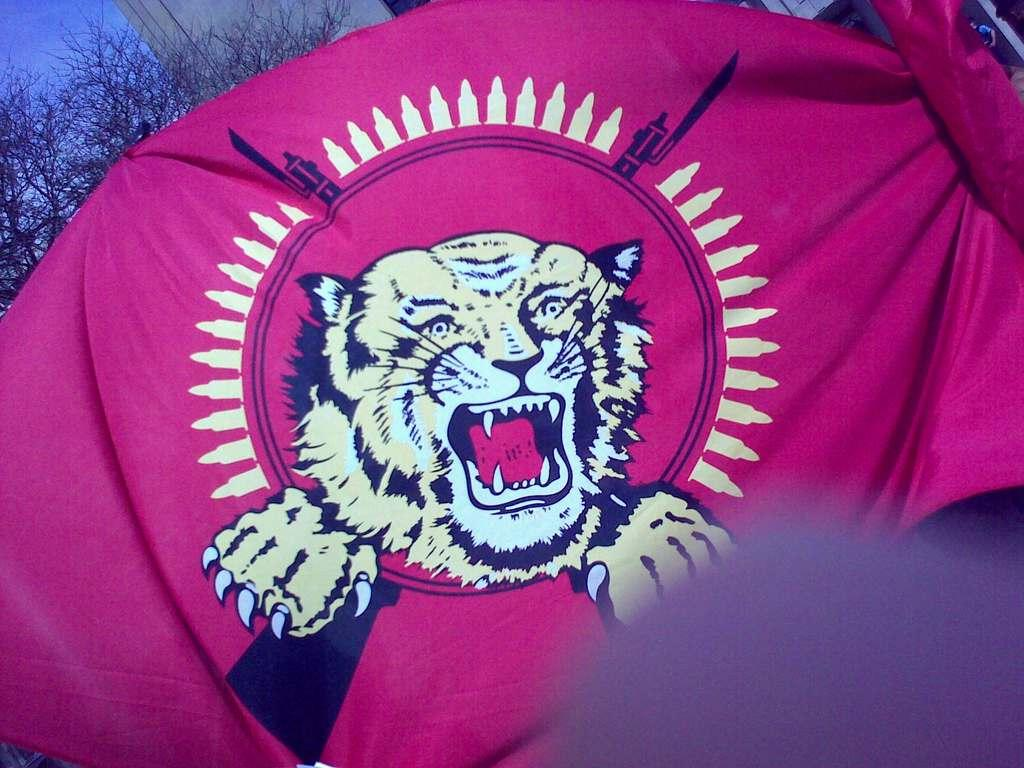What is located in the center of the image? There is cloth in the center of the image. What can be seen in the background of the image? There is a tree and a building in the background of the image. What is visible in the sky in the image? The sky is visible in the background of the image. What type of brain can be seen in the image? There is no brain present in the image. What type of business is being conducted in the image? There is no business activity depicted in the image. 